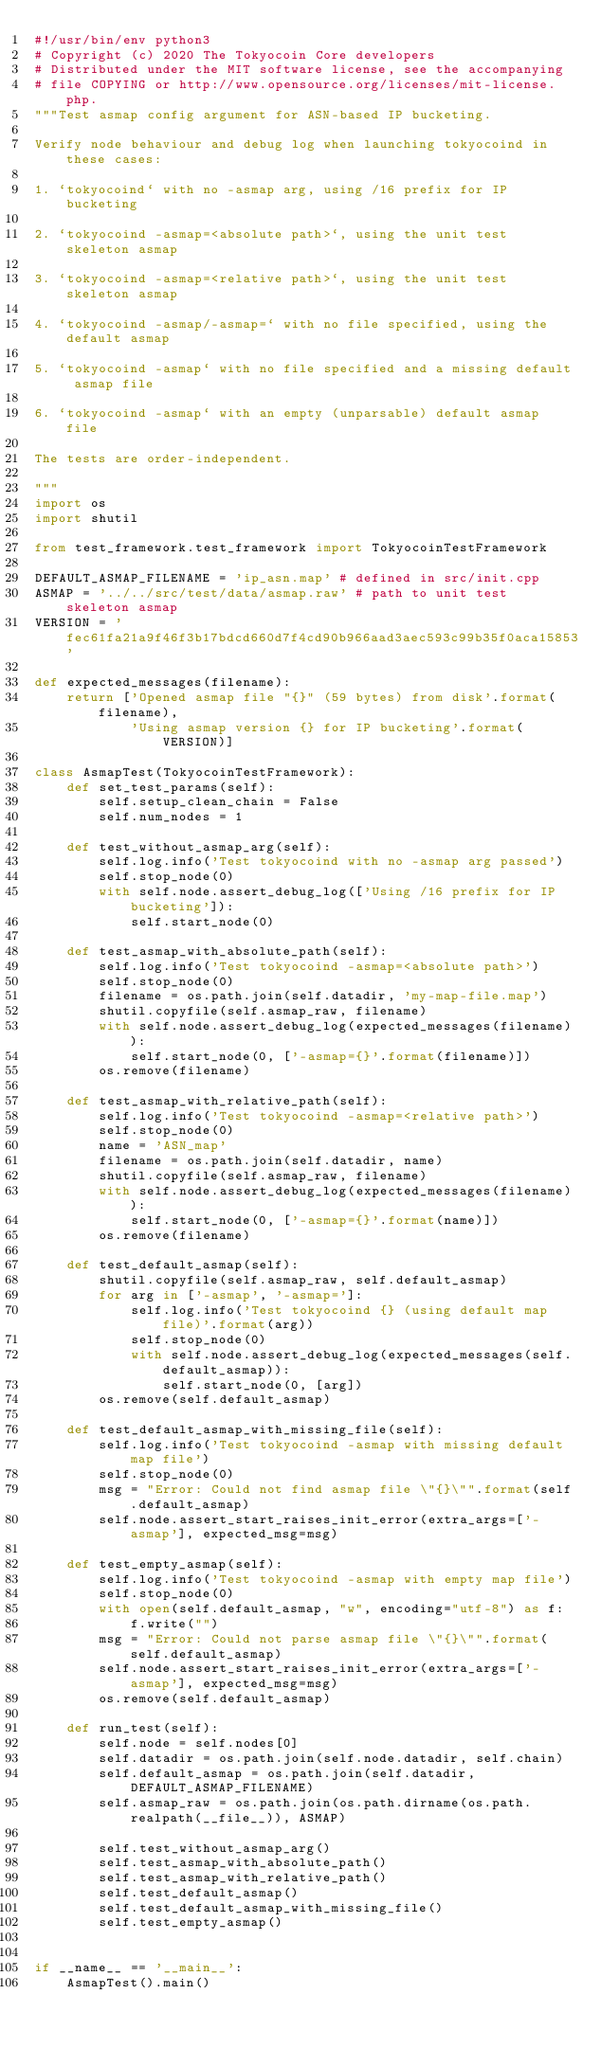<code> <loc_0><loc_0><loc_500><loc_500><_Python_>#!/usr/bin/env python3
# Copyright (c) 2020 The Tokyocoin Core developers
# Distributed under the MIT software license, see the accompanying
# file COPYING or http://www.opensource.org/licenses/mit-license.php.
"""Test asmap config argument for ASN-based IP bucketing.

Verify node behaviour and debug log when launching tokyocoind in these cases:

1. `tokyocoind` with no -asmap arg, using /16 prefix for IP bucketing

2. `tokyocoind -asmap=<absolute path>`, using the unit test skeleton asmap

3. `tokyocoind -asmap=<relative path>`, using the unit test skeleton asmap

4. `tokyocoind -asmap/-asmap=` with no file specified, using the default asmap

5. `tokyocoind -asmap` with no file specified and a missing default asmap file

6. `tokyocoind -asmap` with an empty (unparsable) default asmap file

The tests are order-independent.

"""
import os
import shutil

from test_framework.test_framework import TokyocoinTestFramework

DEFAULT_ASMAP_FILENAME = 'ip_asn.map' # defined in src/init.cpp
ASMAP = '../../src/test/data/asmap.raw' # path to unit test skeleton asmap
VERSION = 'fec61fa21a9f46f3b17bdcd660d7f4cd90b966aad3aec593c99b35f0aca15853'

def expected_messages(filename):
    return ['Opened asmap file "{}" (59 bytes) from disk'.format(filename),
            'Using asmap version {} for IP bucketing'.format(VERSION)]

class AsmapTest(TokyocoinTestFramework):
    def set_test_params(self):
        self.setup_clean_chain = False
        self.num_nodes = 1

    def test_without_asmap_arg(self):
        self.log.info('Test tokyocoind with no -asmap arg passed')
        self.stop_node(0)
        with self.node.assert_debug_log(['Using /16 prefix for IP bucketing']):
            self.start_node(0)

    def test_asmap_with_absolute_path(self):
        self.log.info('Test tokyocoind -asmap=<absolute path>')
        self.stop_node(0)
        filename = os.path.join(self.datadir, 'my-map-file.map')
        shutil.copyfile(self.asmap_raw, filename)
        with self.node.assert_debug_log(expected_messages(filename)):
            self.start_node(0, ['-asmap={}'.format(filename)])
        os.remove(filename)

    def test_asmap_with_relative_path(self):
        self.log.info('Test tokyocoind -asmap=<relative path>')
        self.stop_node(0)
        name = 'ASN_map'
        filename = os.path.join(self.datadir, name)
        shutil.copyfile(self.asmap_raw, filename)
        with self.node.assert_debug_log(expected_messages(filename)):
            self.start_node(0, ['-asmap={}'.format(name)])
        os.remove(filename)

    def test_default_asmap(self):
        shutil.copyfile(self.asmap_raw, self.default_asmap)
        for arg in ['-asmap', '-asmap=']:
            self.log.info('Test tokyocoind {} (using default map file)'.format(arg))
            self.stop_node(0)
            with self.node.assert_debug_log(expected_messages(self.default_asmap)):
                self.start_node(0, [arg])
        os.remove(self.default_asmap)

    def test_default_asmap_with_missing_file(self):
        self.log.info('Test tokyocoind -asmap with missing default map file')
        self.stop_node(0)
        msg = "Error: Could not find asmap file \"{}\"".format(self.default_asmap)
        self.node.assert_start_raises_init_error(extra_args=['-asmap'], expected_msg=msg)

    def test_empty_asmap(self):
        self.log.info('Test tokyocoind -asmap with empty map file')
        self.stop_node(0)
        with open(self.default_asmap, "w", encoding="utf-8") as f:
            f.write("")
        msg = "Error: Could not parse asmap file \"{}\"".format(self.default_asmap)
        self.node.assert_start_raises_init_error(extra_args=['-asmap'], expected_msg=msg)
        os.remove(self.default_asmap)

    def run_test(self):
        self.node = self.nodes[0]
        self.datadir = os.path.join(self.node.datadir, self.chain)
        self.default_asmap = os.path.join(self.datadir, DEFAULT_ASMAP_FILENAME)
        self.asmap_raw = os.path.join(os.path.dirname(os.path.realpath(__file__)), ASMAP)

        self.test_without_asmap_arg()
        self.test_asmap_with_absolute_path()
        self.test_asmap_with_relative_path()
        self.test_default_asmap()
        self.test_default_asmap_with_missing_file()
        self.test_empty_asmap()


if __name__ == '__main__':
    AsmapTest().main()
</code> 